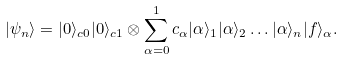Convert formula to latex. <formula><loc_0><loc_0><loc_500><loc_500>| \psi _ { n } \rangle = | 0 \rangle _ { c 0 } | 0 \rangle _ { c 1 } \otimes \sum _ { \alpha = 0 } ^ { 1 } c _ { \alpha } | \alpha \rangle _ { 1 } | \alpha \rangle _ { 2 } \dots | \alpha \rangle _ { n } | f \rangle _ { \alpha } .</formula> 